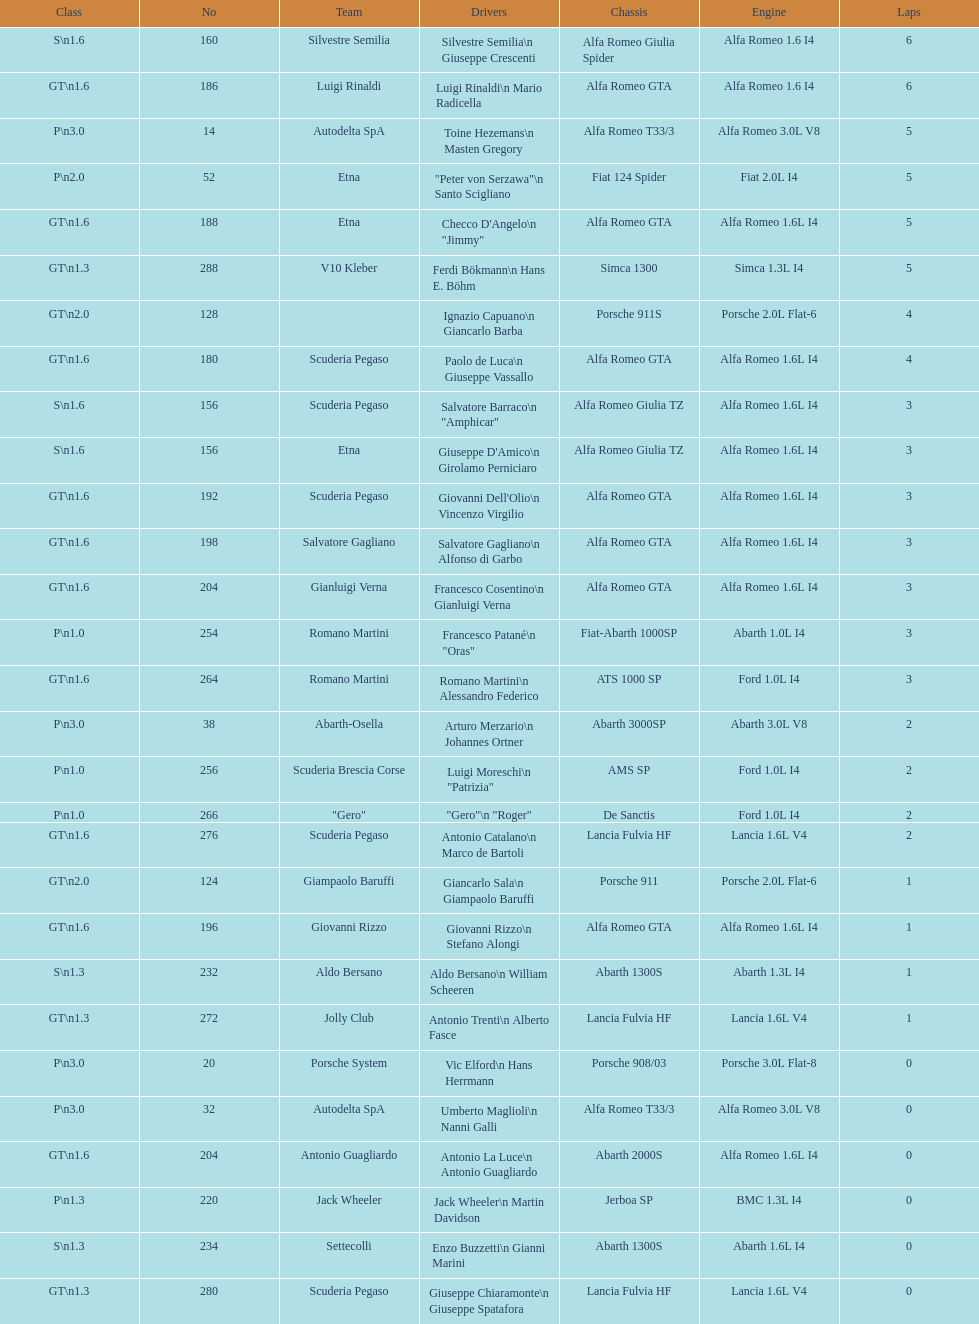After two laps, what number of teams did not complete the race? 4. 